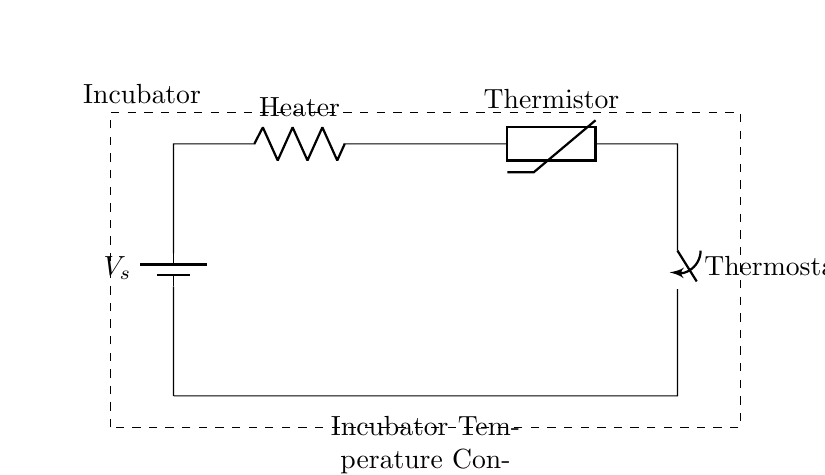What is the function of the heater in the circuit? The heater converts electrical energy into heat, which is necessary for increasing the temperature inside the incubator. It directly influences the incubator's temperature control by heating the air to maintain optimal conditions for microbial growth.
Answer: Heating What component acts as a temperature sensor in the circuit? The thermistor is the temperature sensor used in this circuit. It changes its resistance with temperature changes, providing feedback to maintain the required temperature.
Answer: Thermistor How many components are in series in this circuit? There are three main components in series: the heater, the thermistor, and the thermostat switch. Each component is connected end-to-end, allowing current to flow through them sequentially.
Answer: Three What role does the thermostat play in this circuit? The thermostat acts as a switch that controls the heater based on the temperature readings from the thermistor, turning it on or off to maintain the desired temperature in the incubator.
Answer: Control What will happen if the thermistor fails? If the thermistor fails, the circuit may not accurately read the temperature, potentially leading to either overheating or insufficient heating in the incubator, which can harm the microbial cultures being maintained.
Answer: Overheating What does the battery provide in this circuit? The battery provides the required voltage to the circuit, supplying electrical energy to power the heater and ensure the thermistor and thermostat function correctly.
Answer: Voltage 